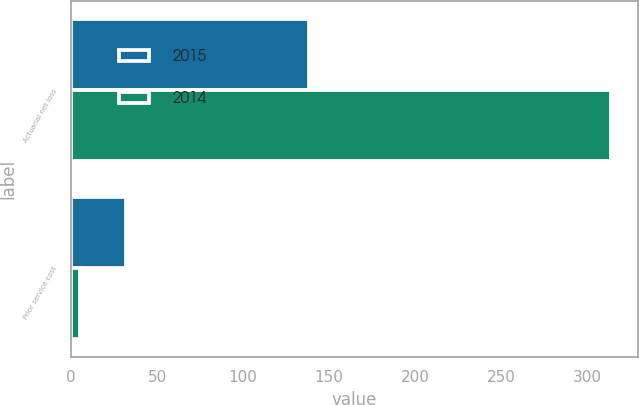Convert chart to OTSL. <chart><loc_0><loc_0><loc_500><loc_500><stacked_bar_chart><ecel><fcel>Actuarial net loss<fcel>Prior service cost<nl><fcel>2015<fcel>138<fcel>32<nl><fcel>2014<fcel>314<fcel>5<nl></chart> 